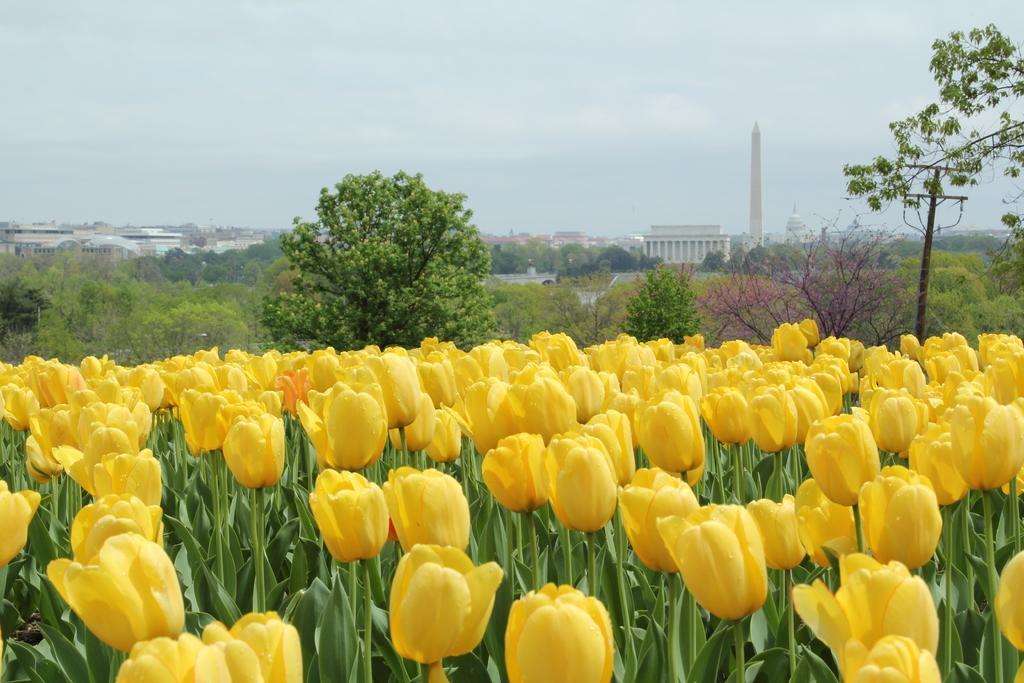Can you describe this image briefly? This picture might be taken from outside of the city. In this image, we can see flowers. In the background, we can also see some trees, buildings, towers. On the top, we can see a sky. 